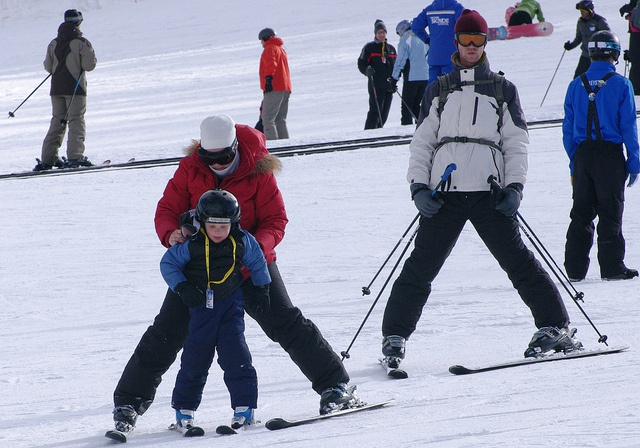Describe the objects in this image and their specific colors. I can see people in darkgray, black, and gray tones, people in darkgray, black, maroon, and gray tones, people in darkgray, black, navy, blue, and darkblue tones, people in darkgray, black, darkblue, navy, and blue tones, and people in darkgray, gray, black, and lavender tones in this image. 